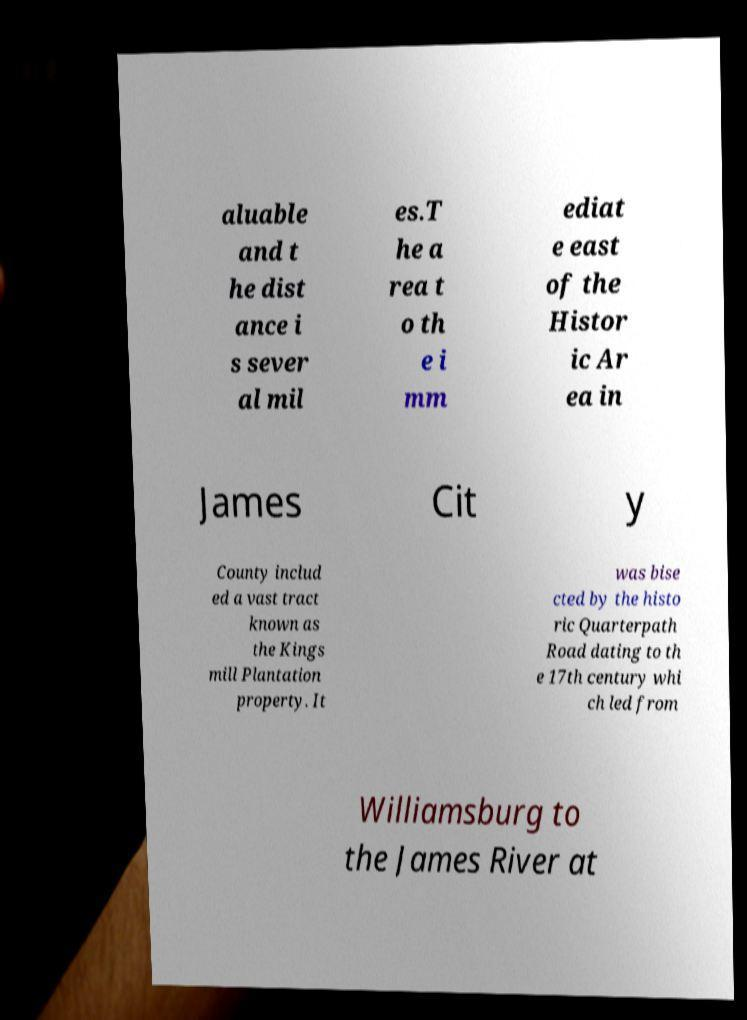For documentation purposes, I need the text within this image transcribed. Could you provide that? aluable and t he dist ance i s sever al mil es.T he a rea t o th e i mm ediat e east of the Histor ic Ar ea in James Cit y County includ ed a vast tract known as the Kings mill Plantation property. It was bise cted by the histo ric Quarterpath Road dating to th e 17th century whi ch led from Williamsburg to the James River at 